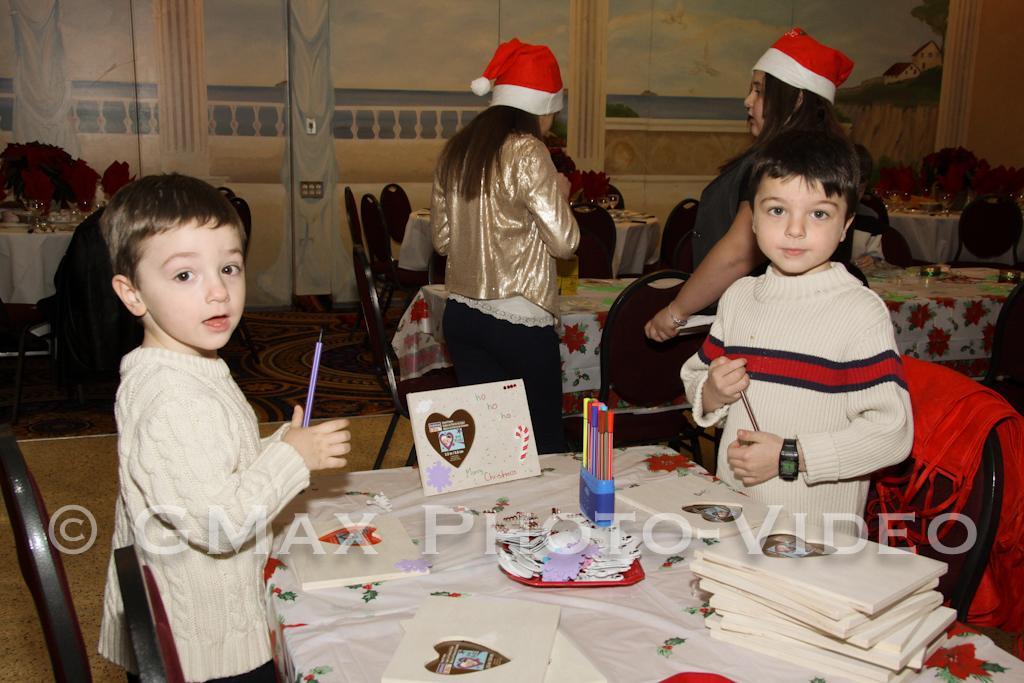Describe this image in one or two sentences. In this image we can see people standing on the floor and tables are placed in front of them. On the tables we can see canvas boards, color pens, photo frame and a table cloth. In the background there are crockery and flower bouquets. 